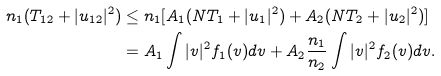<formula> <loc_0><loc_0><loc_500><loc_500>n _ { 1 } ( T _ { 1 2 } + | u _ { 1 2 } | ^ { 2 } ) & \leq n _ { 1 } [ A _ { 1 } ( N T _ { 1 } + | u _ { 1 } | ^ { 2 } ) + A _ { 2 } ( N T _ { 2 } + | u _ { 2 } | ^ { 2 } ) ] \\ & = A _ { 1 } \int | v | ^ { 2 } f _ { 1 } ( v ) d v + A _ { 2 } \frac { n _ { 1 } } { n _ { 2 } } \int | v | ^ { 2 } f _ { 2 } ( v ) d v .</formula> 